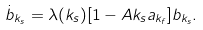Convert formula to latex. <formula><loc_0><loc_0><loc_500><loc_500>\dot { b } _ { k _ { s } } = \lambda ( k _ { s } ) [ 1 - A k _ { s } a _ { k _ { f } } ] { b } _ { k _ { s } } .</formula> 